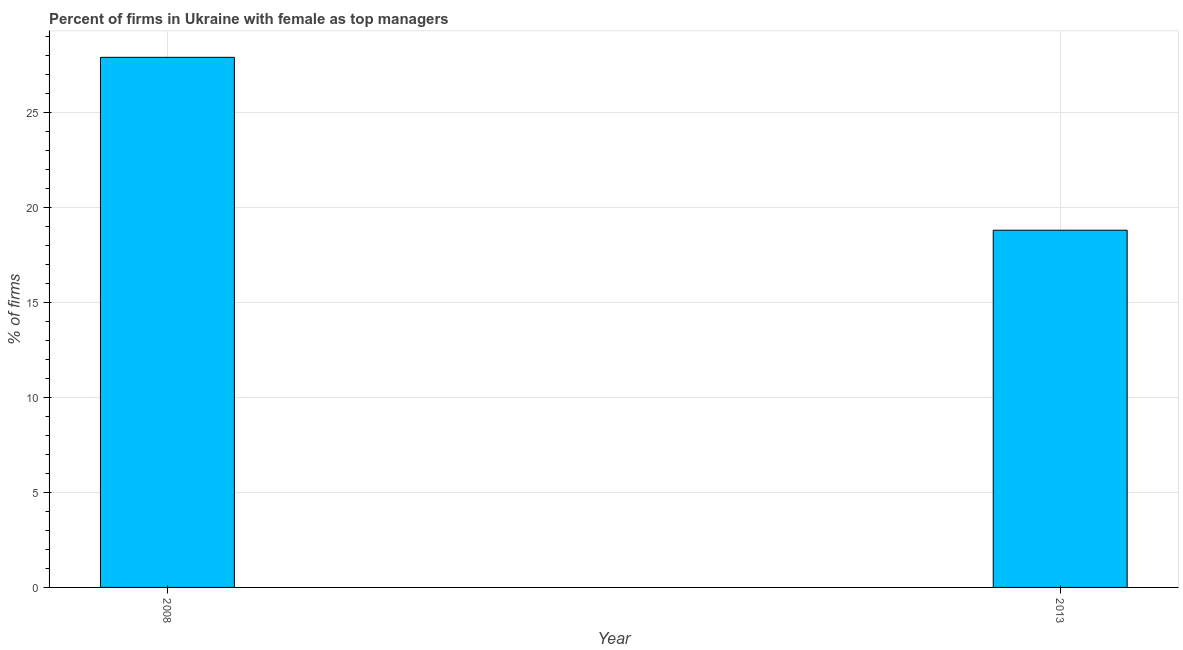What is the title of the graph?
Give a very brief answer. Percent of firms in Ukraine with female as top managers. What is the label or title of the X-axis?
Your answer should be compact. Year. What is the label or title of the Y-axis?
Provide a short and direct response. % of firms. What is the percentage of firms with female as top manager in 2013?
Your response must be concise. 18.8. Across all years, what is the maximum percentage of firms with female as top manager?
Ensure brevity in your answer.  27.9. In which year was the percentage of firms with female as top manager maximum?
Make the answer very short. 2008. What is the sum of the percentage of firms with female as top manager?
Provide a short and direct response. 46.7. What is the average percentage of firms with female as top manager per year?
Keep it short and to the point. 23.35. What is the median percentage of firms with female as top manager?
Offer a terse response. 23.35. In how many years, is the percentage of firms with female as top manager greater than 1 %?
Provide a succinct answer. 2. Do a majority of the years between 2008 and 2013 (inclusive) have percentage of firms with female as top manager greater than 11 %?
Ensure brevity in your answer.  Yes. What is the ratio of the percentage of firms with female as top manager in 2008 to that in 2013?
Keep it short and to the point. 1.48. Is the percentage of firms with female as top manager in 2008 less than that in 2013?
Provide a succinct answer. No. What is the difference between two consecutive major ticks on the Y-axis?
Make the answer very short. 5. What is the % of firms of 2008?
Ensure brevity in your answer.  27.9. What is the ratio of the % of firms in 2008 to that in 2013?
Your response must be concise. 1.48. 